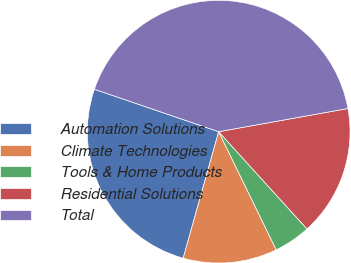Convert chart. <chart><loc_0><loc_0><loc_500><loc_500><pie_chart><fcel>Automation Solutions<fcel>Climate Technologies<fcel>Tools & Home Products<fcel>Residential Solutions<fcel>Total<nl><fcel>25.88%<fcel>11.57%<fcel>4.52%<fcel>16.09%<fcel>41.94%<nl></chart> 